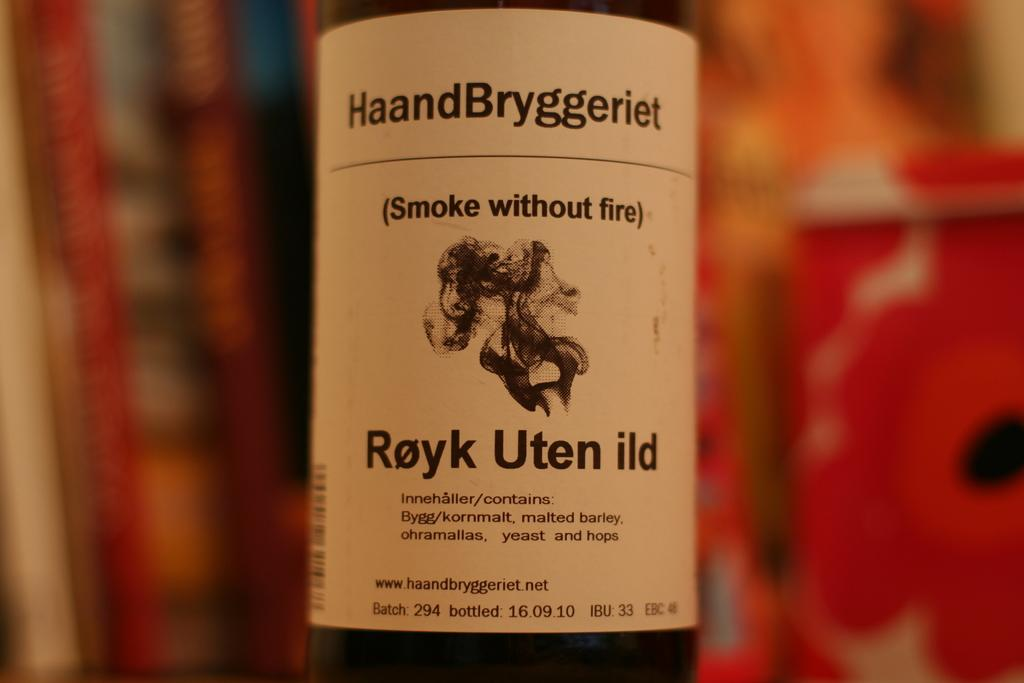What object can be seen in the image? There is a bottle in the image. Can you describe the bottle further? The bottle has a label attached to it. How does the bottle perform division in the image? The bottle does not perform division in the image, as it is an inanimate object and cannot perform mathematical operations. 